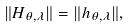<formula> <loc_0><loc_0><loc_500><loc_500>\| H _ { \theta , \lambda } \| = \| h _ { \theta , \lambda } \| ,</formula> 